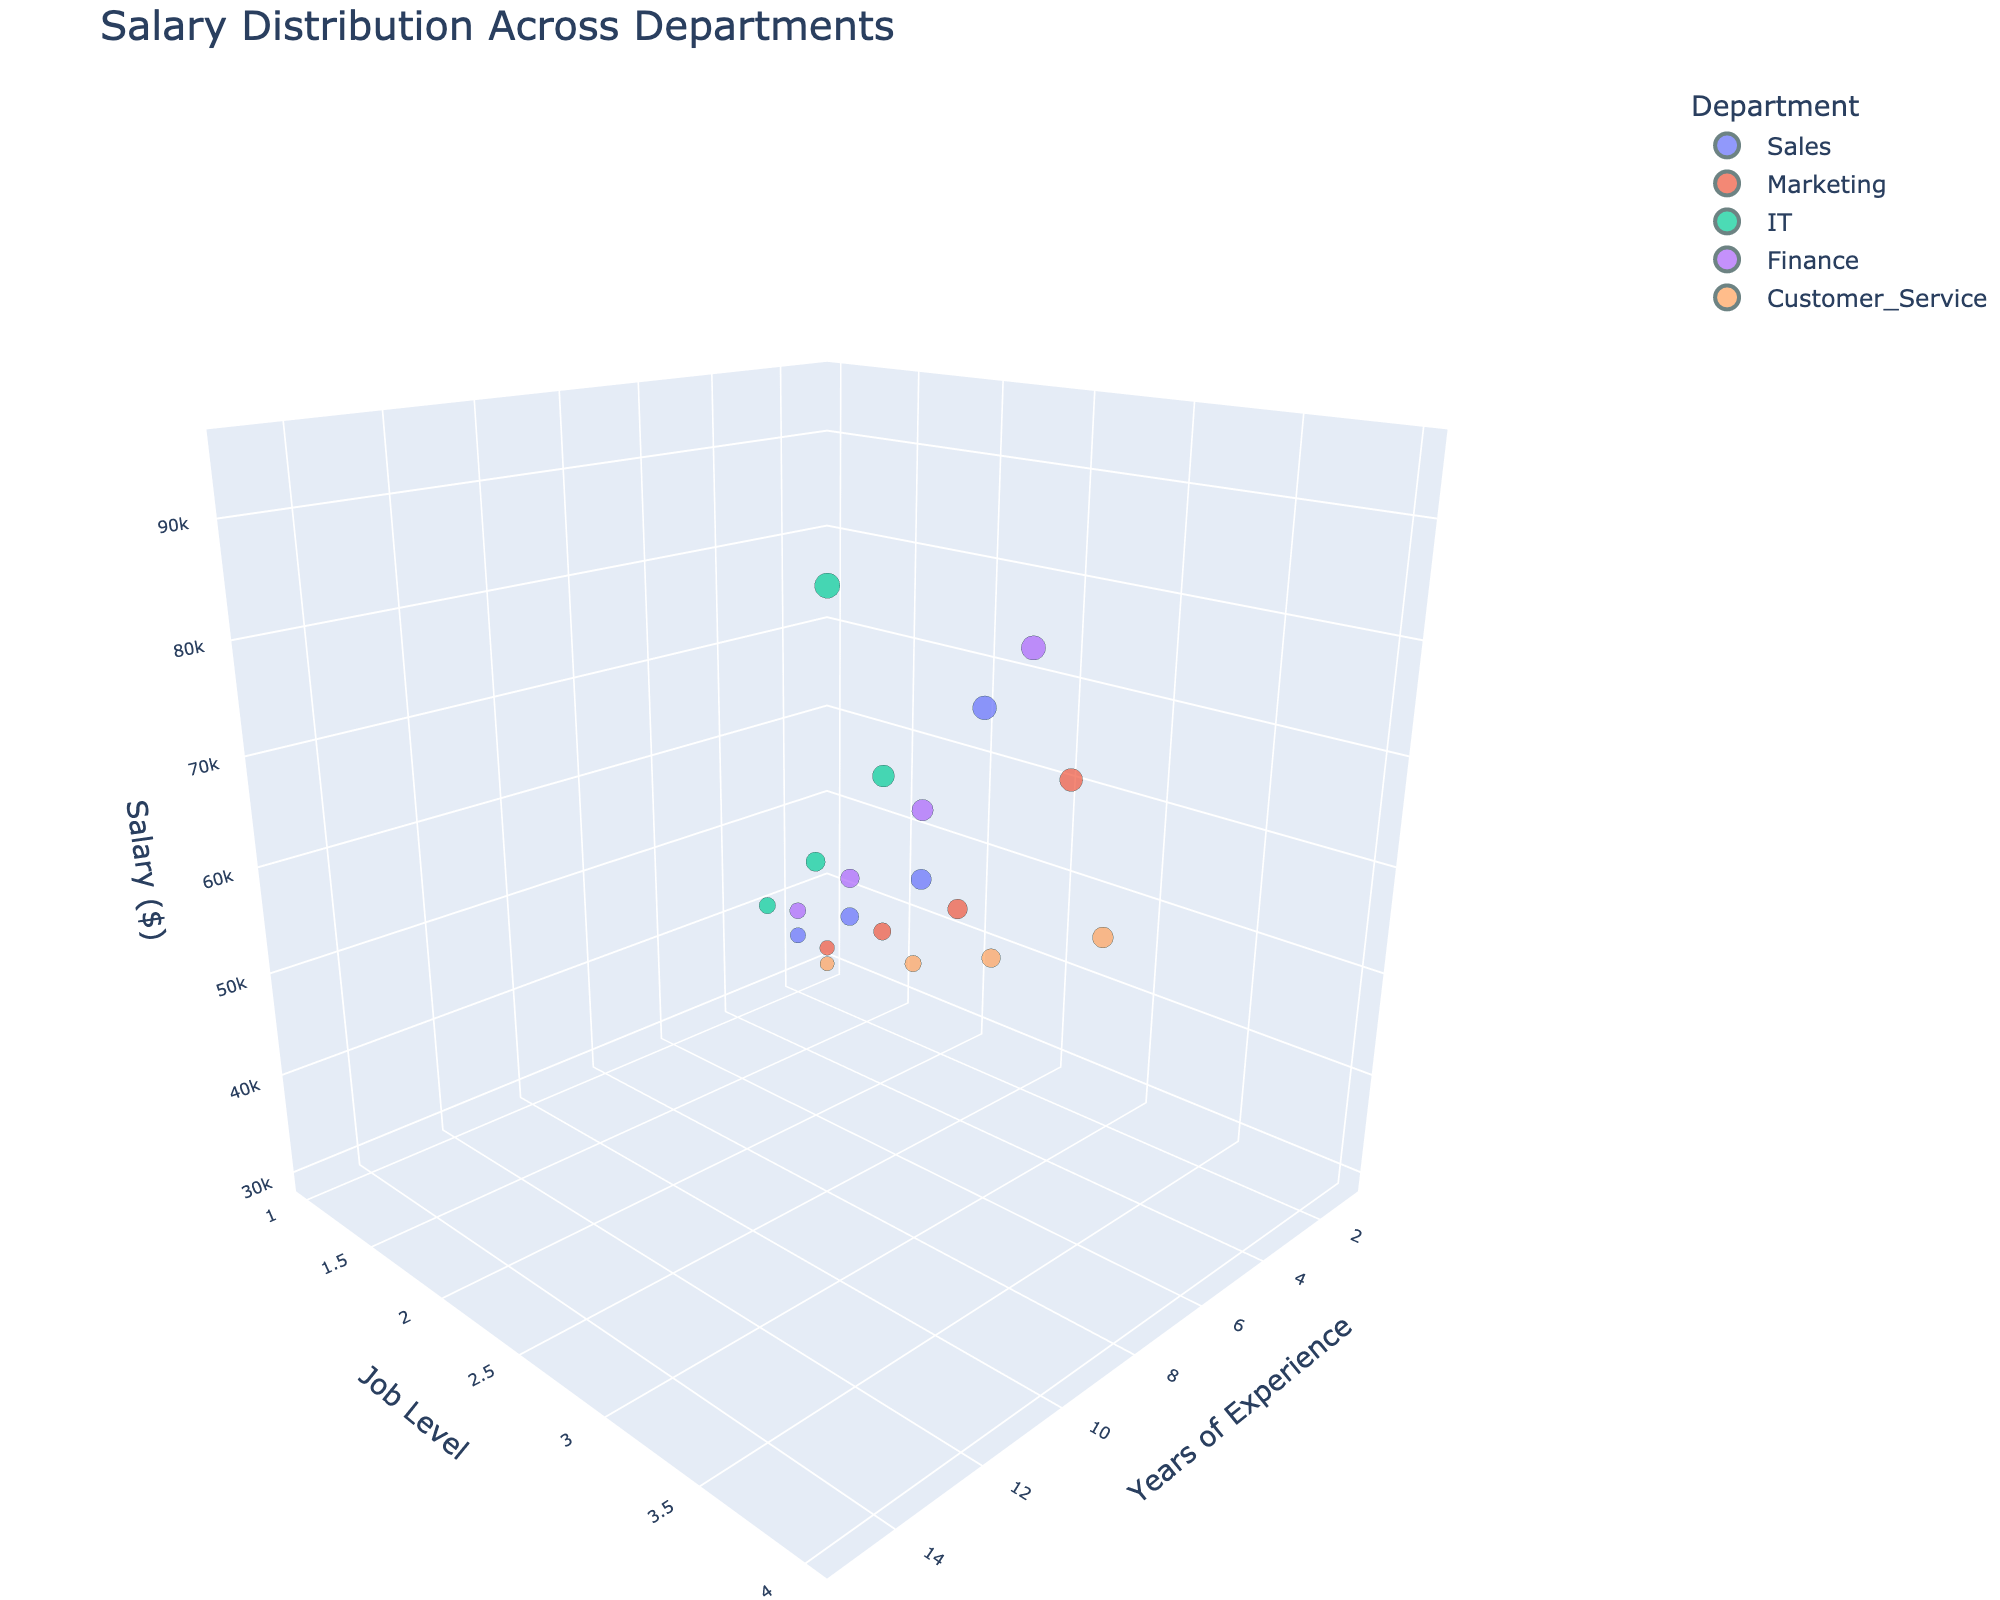What's the title of the plot? The title is usually located at the top of the plot and is a clear descriptor of the content. In this case, it describes the main subject of the 3D scatter plot.
Answer: Salary Distribution Across Departments What do the axes represent in the figure? Axes typically denote different dimensions of the data. For this plot, the x-axis represents 'Years of Experience', the y-axis represents 'Job Level', and the z-axis represents 'Salary ($)'.
Answer: Years of Experience, Job Level, Salary ($) Which department has the highest salary point and what is that salary? The IT department has the highest data point at 95,000 dollars which is located at 15 years of experience and job level 4.
Answer: IT, 95,000 dollars Is there any department with a job level 4 and a salary less than 70,000 dollars? To find this, we need to look at the data points corresponding to job level 4. We see that no department with job level 4 has a salary less than 70,000 dollars.
Answer: No Which department has the most dispersed salary distribution? By observing the spread of the data points along the z-axis for each department's color, we see that the Sales department has the most dispersed salary distribution, covering a wider range of salaries from 35,000 to 85,000 dollars.
Answer: Sales What's the average salary of department Finance across all job levels? To compute the average salary for the Finance department, we sum the salaries (38,000 + 52,000 + 68,000 + 88,000) which equals 246,000 dollars. Dividing this sum by 4, we get an average salary of 61,500 dollars.
Answer: 61,500 dollars Which department has the lowest starting salary and what is it? Looking at the lowest job levels (job level 1), we can see that Customer Service has the lowest starting salary at 30,000 dollars.
Answer: Customer Service, 30,000 dollars At job level 3, which department has the highest salary? For job level 3, comparing the salaries across departments, the IT department has the highest salary of 72,000 dollars.
Answer: IT Do Marketing and Finance departments have any overlap in their salary distributions? By observing the ranges of salaries for both departments in the plot, we see that the salaries for Marketing (32,000 to 78,000 dollars) and Finance (38,000 to 88,000 dollars) do overlap, particularly in the range from 38,000 to 78,000 dollars.
Answer: Yes Are there more data points (employees) in the Sales department or the IT department? By counting the number of data points for each department, we see that both Sales and IT departments have four data points each.
Answer: Equal (4 data points each) 